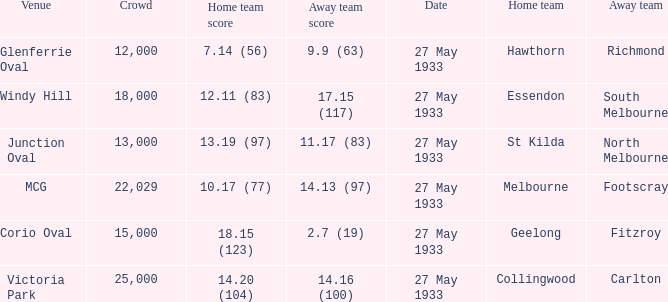During st kilda's home game, what was the number of people in the crowd? 13000.0. 